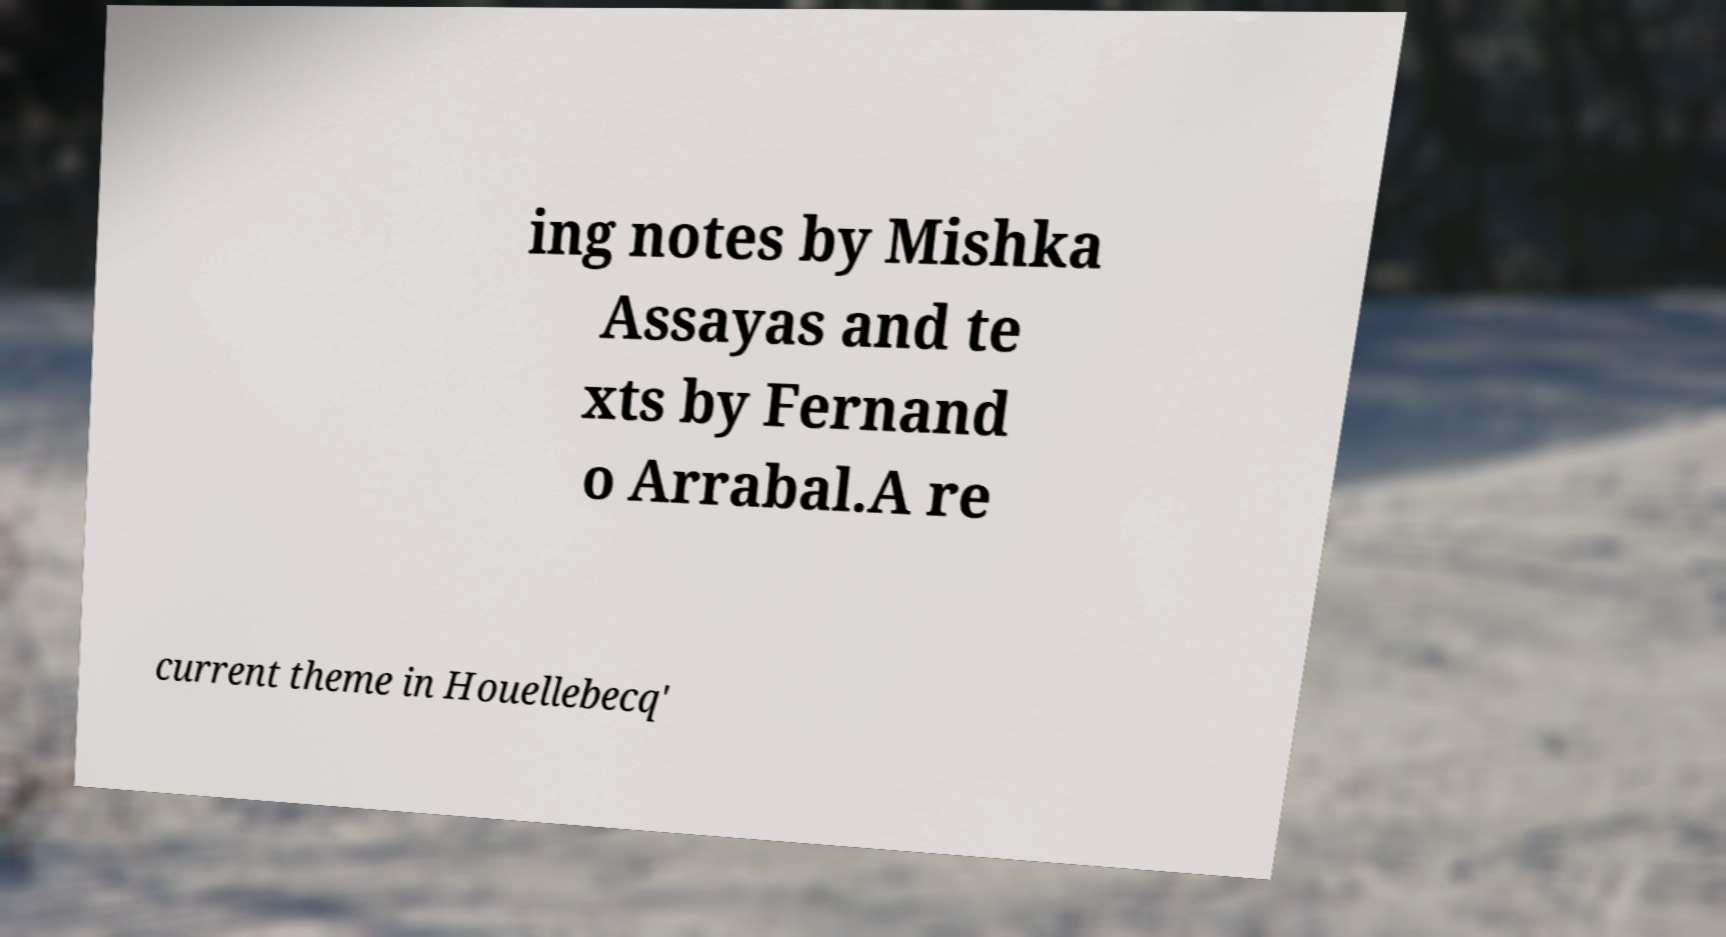There's text embedded in this image that I need extracted. Can you transcribe it verbatim? ing notes by Mishka Assayas and te xts by Fernand o Arrabal.A re current theme in Houellebecq' 